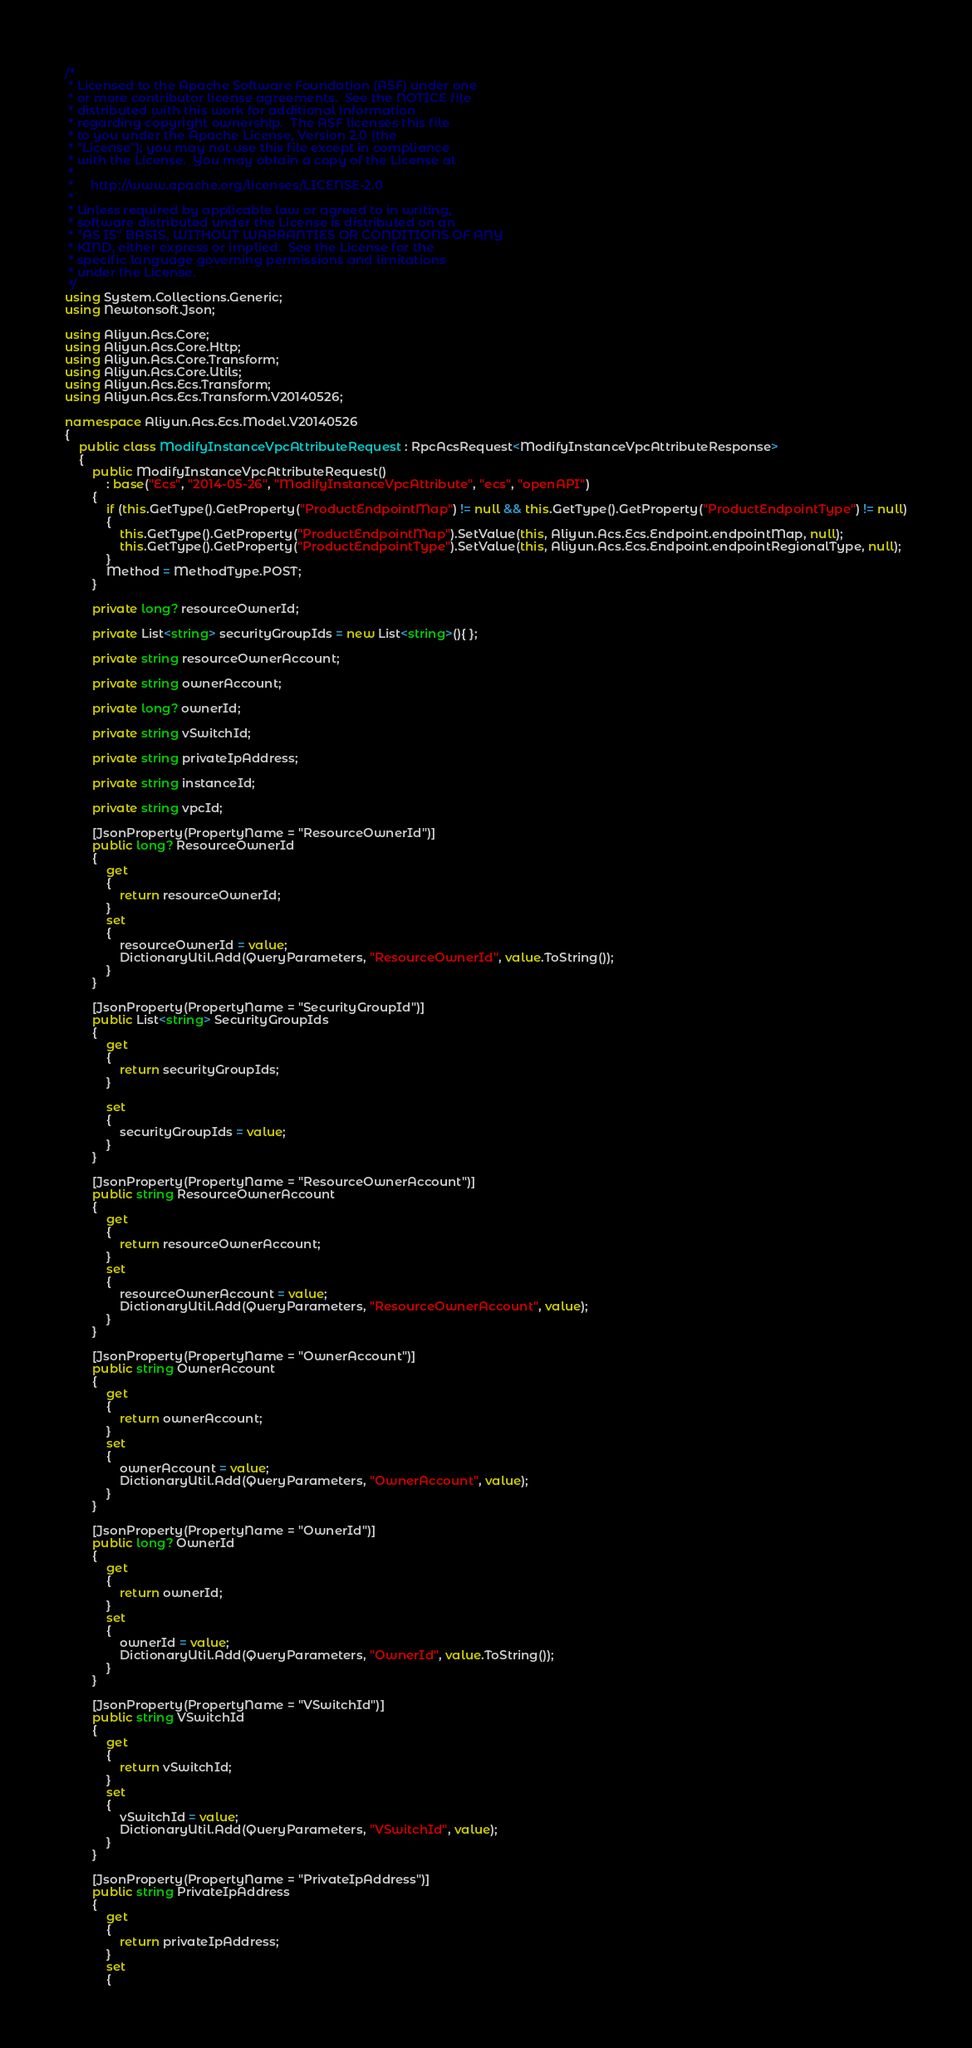<code> <loc_0><loc_0><loc_500><loc_500><_C#_>/*
 * Licensed to the Apache Software Foundation (ASF) under one
 * or more contributor license agreements.  See the NOTICE file
 * distributed with this work for additional information
 * regarding copyright ownership.  The ASF licenses this file
 * to you under the Apache License, Version 2.0 (the
 * "License"); you may not use this file except in compliance
 * with the License.  You may obtain a copy of the License at
 *
 *     http://www.apache.org/licenses/LICENSE-2.0
 *
 * Unless required by applicable law or agreed to in writing,
 * software distributed under the License is distributed on an
 * "AS IS" BASIS, WITHOUT WARRANTIES OR CONDITIONS OF ANY
 * KIND, either express or implied.  See the License for the
 * specific language governing permissions and limitations
 * under the License.
 */
using System.Collections.Generic;
using Newtonsoft.Json;

using Aliyun.Acs.Core;
using Aliyun.Acs.Core.Http;
using Aliyun.Acs.Core.Transform;
using Aliyun.Acs.Core.Utils;
using Aliyun.Acs.Ecs.Transform;
using Aliyun.Acs.Ecs.Transform.V20140526;

namespace Aliyun.Acs.Ecs.Model.V20140526
{
    public class ModifyInstanceVpcAttributeRequest : RpcAcsRequest<ModifyInstanceVpcAttributeResponse>
    {
        public ModifyInstanceVpcAttributeRequest()
            : base("Ecs", "2014-05-26", "ModifyInstanceVpcAttribute", "ecs", "openAPI")
        {
            if (this.GetType().GetProperty("ProductEndpointMap") != null && this.GetType().GetProperty("ProductEndpointType") != null)
            {
                this.GetType().GetProperty("ProductEndpointMap").SetValue(this, Aliyun.Acs.Ecs.Endpoint.endpointMap, null);
                this.GetType().GetProperty("ProductEndpointType").SetValue(this, Aliyun.Acs.Ecs.Endpoint.endpointRegionalType, null);
            }
			Method = MethodType.POST;
        }

		private long? resourceOwnerId;

		private List<string> securityGroupIds = new List<string>(){ };

		private string resourceOwnerAccount;

		private string ownerAccount;

		private long? ownerId;

		private string vSwitchId;

		private string privateIpAddress;

		private string instanceId;

		private string vpcId;

		[JsonProperty(PropertyName = "ResourceOwnerId")]
		public long? ResourceOwnerId
		{
			get
			{
				return resourceOwnerId;
			}
			set	
			{
				resourceOwnerId = value;
				DictionaryUtil.Add(QueryParameters, "ResourceOwnerId", value.ToString());
			}
		}

		[JsonProperty(PropertyName = "SecurityGroupId")]
		public List<string> SecurityGroupIds
		{
			get
			{
				return securityGroupIds;
			}

			set
			{
				securityGroupIds = value;
			}
		}

		[JsonProperty(PropertyName = "ResourceOwnerAccount")]
		public string ResourceOwnerAccount
		{
			get
			{
				return resourceOwnerAccount;
			}
			set	
			{
				resourceOwnerAccount = value;
				DictionaryUtil.Add(QueryParameters, "ResourceOwnerAccount", value);
			}
		}

		[JsonProperty(PropertyName = "OwnerAccount")]
		public string OwnerAccount
		{
			get
			{
				return ownerAccount;
			}
			set	
			{
				ownerAccount = value;
				DictionaryUtil.Add(QueryParameters, "OwnerAccount", value);
			}
		}

		[JsonProperty(PropertyName = "OwnerId")]
		public long? OwnerId
		{
			get
			{
				return ownerId;
			}
			set	
			{
				ownerId = value;
				DictionaryUtil.Add(QueryParameters, "OwnerId", value.ToString());
			}
		}

		[JsonProperty(PropertyName = "VSwitchId")]
		public string VSwitchId
		{
			get
			{
				return vSwitchId;
			}
			set	
			{
				vSwitchId = value;
				DictionaryUtil.Add(QueryParameters, "VSwitchId", value);
			}
		}

		[JsonProperty(PropertyName = "PrivateIpAddress")]
		public string PrivateIpAddress
		{
			get
			{
				return privateIpAddress;
			}
			set	
			{</code> 